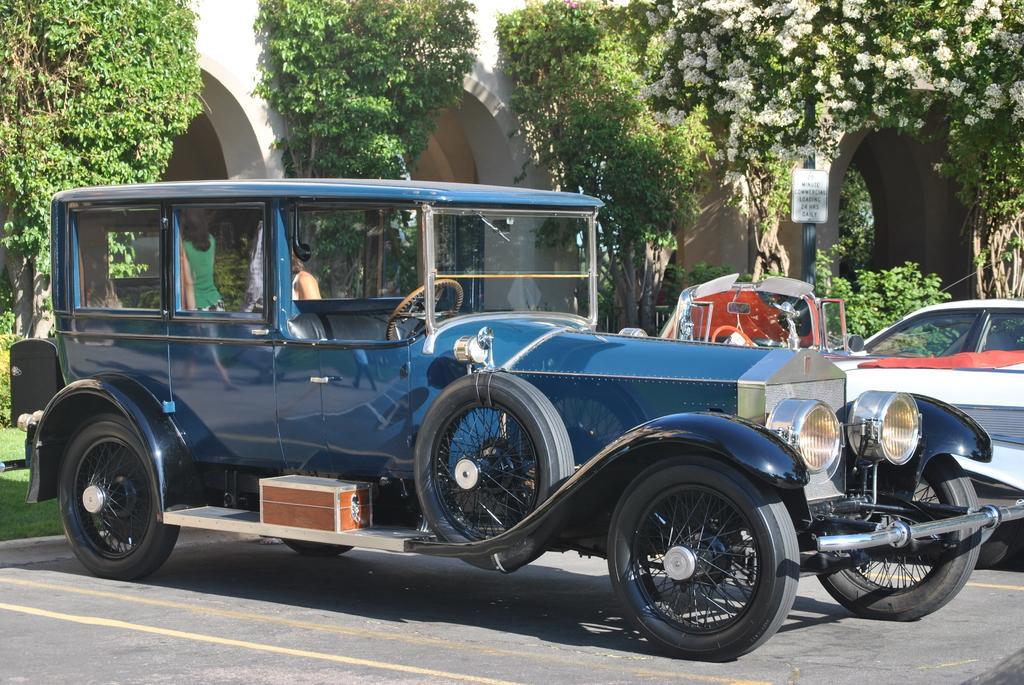Please provide a concise description of this image. In the picture we can see a vintage car which is blue in color and we can see some cars also parked near the path and in the background we can see a grass, plants, and a building wall. 